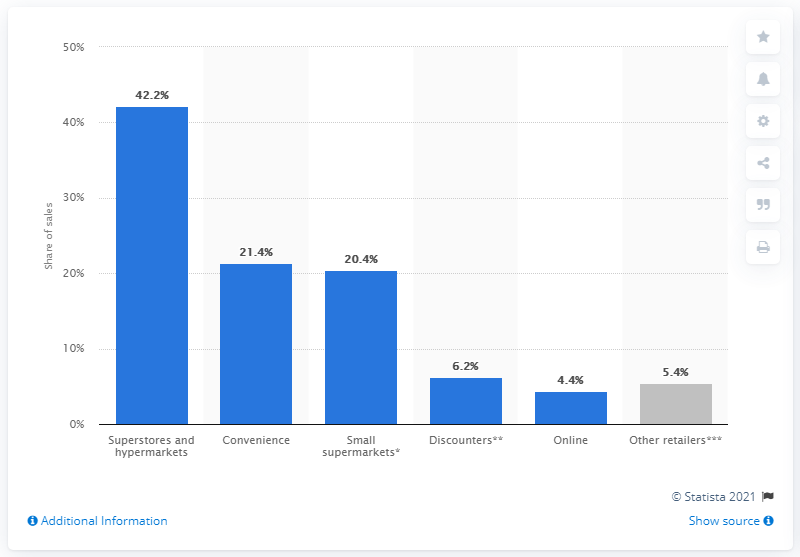Highlight a few significant elements in this photo. Superstores and hypermarkets account for the largest share of sales at 42.2%. 